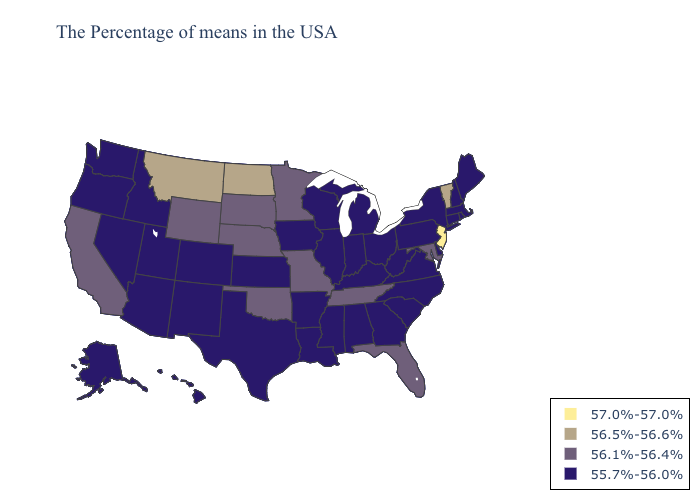Name the states that have a value in the range 55.7%-56.0%?
Quick response, please. Maine, Massachusetts, Rhode Island, New Hampshire, Connecticut, New York, Delaware, Pennsylvania, Virginia, North Carolina, South Carolina, West Virginia, Ohio, Georgia, Michigan, Kentucky, Indiana, Alabama, Wisconsin, Illinois, Mississippi, Louisiana, Arkansas, Iowa, Kansas, Texas, Colorado, New Mexico, Utah, Arizona, Idaho, Nevada, Washington, Oregon, Alaska, Hawaii. What is the highest value in the USA?
Concise answer only. 57.0%-57.0%. Does Vermont have the lowest value in the Northeast?
Concise answer only. No. Does New Mexico have the highest value in the USA?
Be succinct. No. Does the map have missing data?
Keep it brief. No. Among the states that border Wyoming , which have the lowest value?
Be succinct. Colorado, Utah, Idaho. What is the value of Nevada?
Short answer required. 55.7%-56.0%. Is the legend a continuous bar?
Quick response, please. No. What is the lowest value in the USA?
Be succinct. 55.7%-56.0%. Among the states that border Oregon , which have the highest value?
Keep it brief. California. What is the value of Connecticut?
Keep it brief. 55.7%-56.0%. Name the states that have a value in the range 57.0%-57.0%?
Write a very short answer. New Jersey. Which states have the highest value in the USA?
Write a very short answer. New Jersey. Among the states that border Rhode Island , which have the highest value?
Be succinct. Massachusetts, Connecticut. 